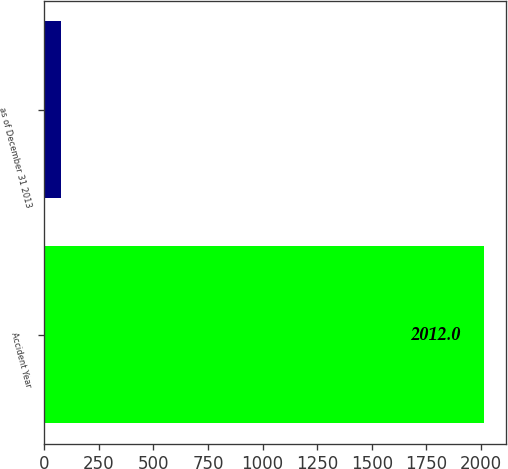Convert chart to OTSL. <chart><loc_0><loc_0><loc_500><loc_500><bar_chart><fcel>Accident Year<fcel>as of December 31 2013<nl><fcel>2012<fcel>75.2<nl></chart> 